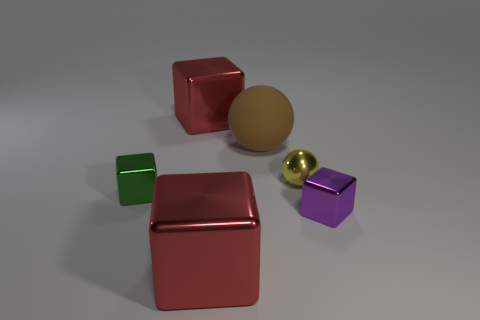Subtract 2 cubes. How many cubes are left? 2 Subtract all green cubes. How many cubes are left? 3 Subtract all gray cubes. Subtract all cyan balls. How many cubes are left? 4 Add 2 yellow shiny objects. How many objects exist? 8 Subtract all spheres. How many objects are left? 4 Subtract 0 blue spheres. How many objects are left? 6 Subtract all cyan matte cylinders. Subtract all green objects. How many objects are left? 5 Add 5 tiny objects. How many tiny objects are left? 8 Add 1 big metallic objects. How many big metallic objects exist? 3 